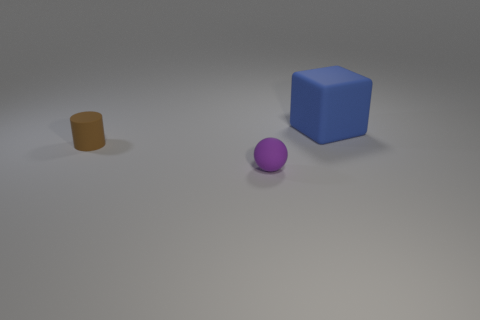What shape is the tiny brown object that is the same material as the small ball?
Keep it short and to the point. Cylinder. How many large objects are either gray metal cylinders or brown cylinders?
Give a very brief answer. 0. Are there any large blue rubber things behind the matte object to the left of the purple matte ball?
Your response must be concise. Yes. Are there any purple spheres?
Your answer should be compact. Yes. The object that is to the right of the small thing in front of the brown rubber cylinder is what color?
Ensure brevity in your answer.  Blue. What number of other rubber cylinders are the same size as the brown cylinder?
Provide a short and direct response. 0. There is a brown cylinder that is made of the same material as the cube; what size is it?
Your answer should be very brief. Small. How many tiny brown rubber things are there?
Offer a terse response. 1. Is there a small purple ball made of the same material as the large cube?
Offer a terse response. Yes. How many things are both behind the tiny purple matte ball and in front of the large blue matte cube?
Make the answer very short. 1. 